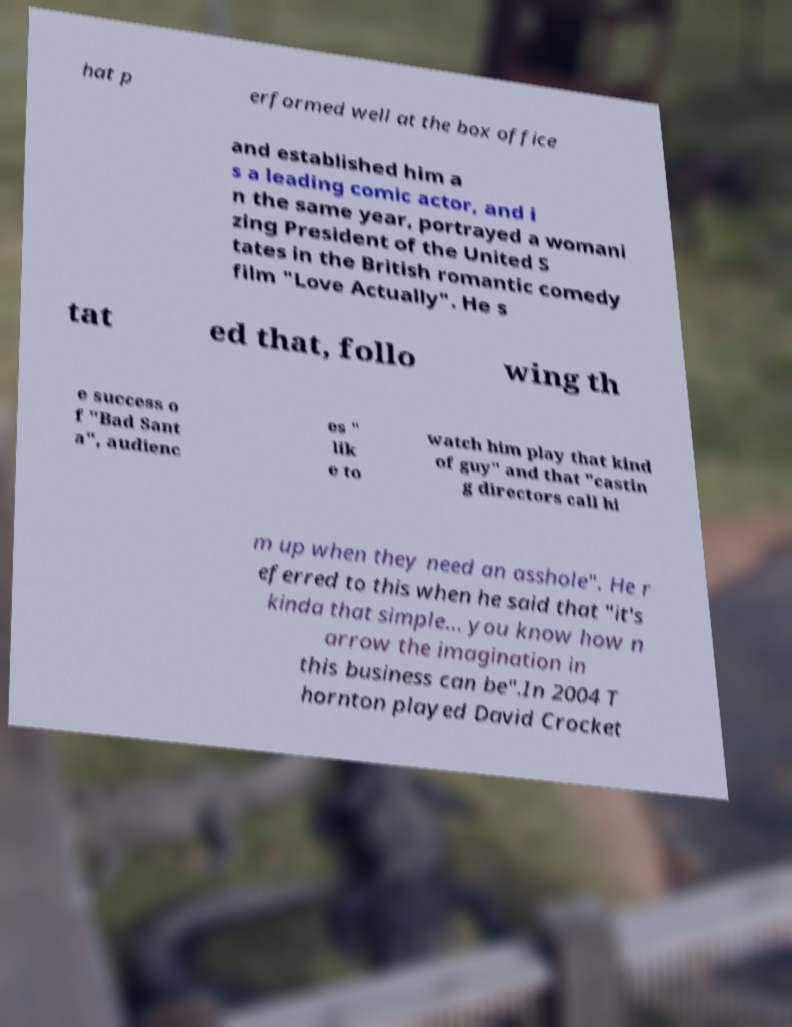Can you read and provide the text displayed in the image?This photo seems to have some interesting text. Can you extract and type it out for me? hat p erformed well at the box office and established him a s a leading comic actor, and i n the same year, portrayed a womani zing President of the United S tates in the British romantic comedy film "Love Actually". He s tat ed that, follo wing th e success o f "Bad Sant a", audienc es " lik e to watch him play that kind of guy" and that "castin g directors call hi m up when they need an asshole". He r eferred to this when he said that "it's kinda that simple... you know how n arrow the imagination in this business can be".In 2004 T hornton played David Crocket 